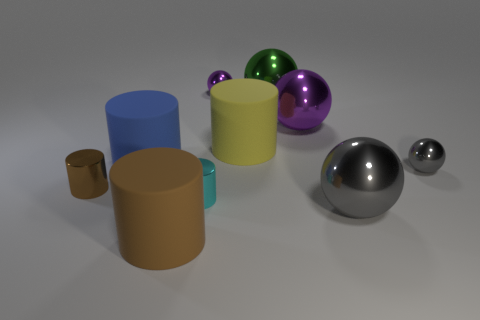Subtract all green spheres. How many spheres are left? 4 Subtract all big blue cylinders. How many cylinders are left? 4 Subtract all cyan cylinders. Subtract all blue cubes. How many cylinders are left? 4 Add 9 green metal balls. How many green metal balls are left? 10 Add 9 cyan cylinders. How many cyan cylinders exist? 10 Subtract 1 green balls. How many objects are left? 9 Subtract all blue cylinders. Subtract all large green spheres. How many objects are left? 8 